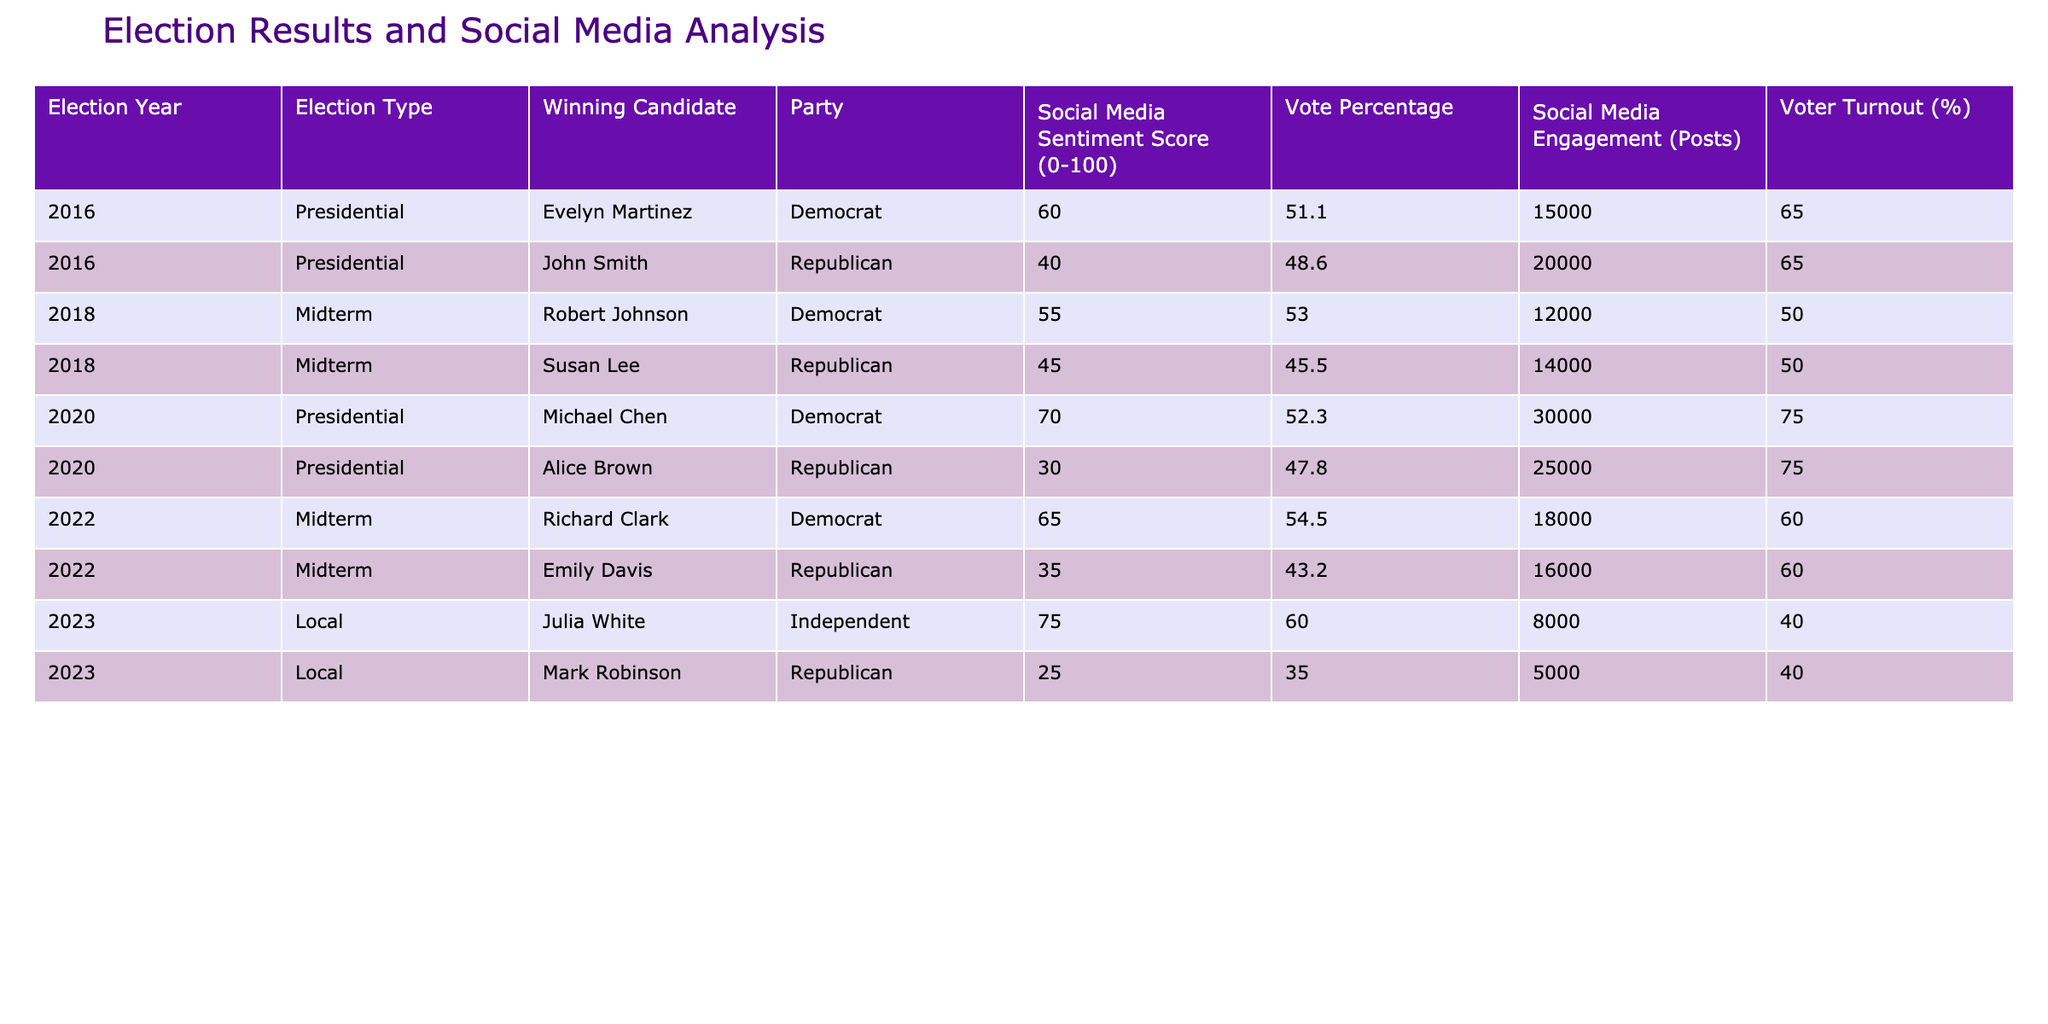What was the voter turnout percentage for the Presidential election in 2016? The table indicates a voter turnout of 65% for both the Democrat and Republican candidates in the 2016 Presidential election.
Answer: 65% How many total posts were made about the winning candidates in the elections of 2018? The winning candidate for the midterm election in 2018 was Robert Johnson, who had 12,000 posts. The losing candidate, Susan Lee, had 14,000 posts. Thus, the total number of posts made about the winning candidates is 12,000 + 14,000 = 26,000.
Answer: 26,000 Is it true that the winning candidate in 2023 had a higher social media sentiment score than the winning candidate in 2020? Yes, Julia White, the winner in 2023, had a social media sentiment score of 75, while Michael Chen, the winner in 2020, had a score of 70.
Answer: Yes What is the average social media engagement for all the winners of the elections listed? To find the average, we add the social media engagement of all winners: 15,000 + 12,000 + 30,000 + 18,000 + 8,000 = 83,000. There are 5 winners, so the average is 83,000 / 5 = 16,600.
Answer: 16,600 How does the vote percentage of the winning candidate for the 2022 midterm compare to that of the 2020 presidential election? Richard Clark, the winning candidate for the 2022 midterm, had a vote percentage of 54.5%, while Michael Chen in the 2020 presidential election had 52.3%. So, 54.5% is higher than 52.3%.
Answer: 54.5% is higher 